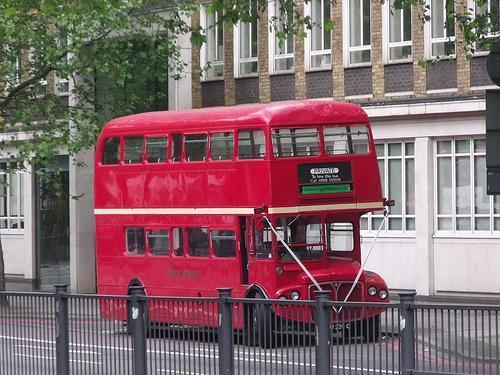How many buses are visible?
Give a very brief answer. 1. 